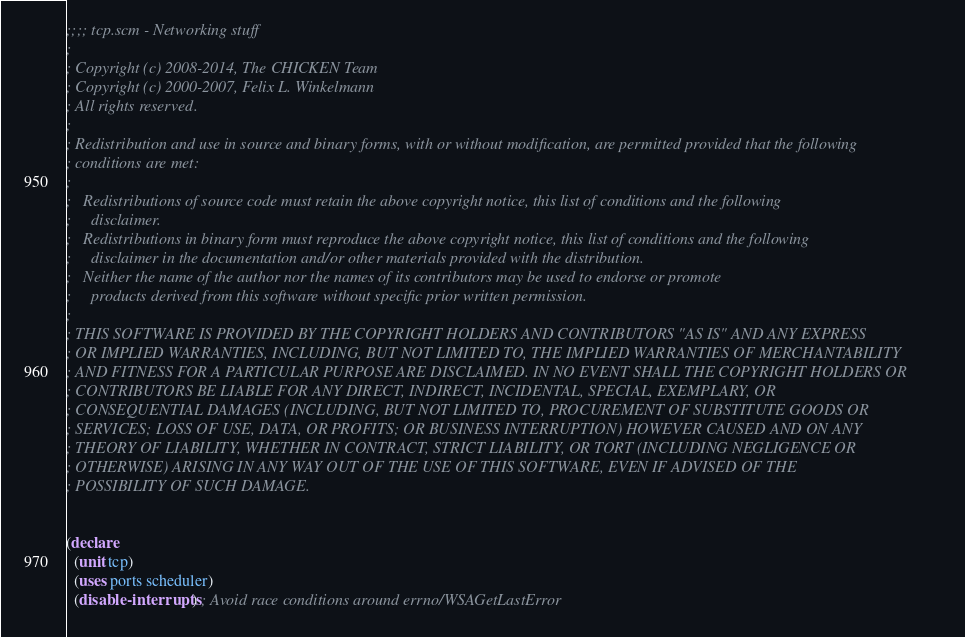Convert code to text. <code><loc_0><loc_0><loc_500><loc_500><_Scheme_>;;;; tcp.scm - Networking stuff
;
; Copyright (c) 2008-2014, The CHICKEN Team
; Copyright (c) 2000-2007, Felix L. Winkelmann
; All rights reserved.
;
; Redistribution and use in source and binary forms, with or without modification, are permitted provided that the following
; conditions are met:
;
;   Redistributions of source code must retain the above copyright notice, this list of conditions and the following
;     disclaimer. 
;   Redistributions in binary form must reproduce the above copyright notice, this list of conditions and the following
;     disclaimer in the documentation and/or other materials provided with the distribution. 
;   Neither the name of the author nor the names of its contributors may be used to endorse or promote
;     products derived from this software without specific prior written permission. 
;
; THIS SOFTWARE IS PROVIDED BY THE COPYRIGHT HOLDERS AND CONTRIBUTORS "AS IS" AND ANY EXPRESS
; OR IMPLIED WARRANTIES, INCLUDING, BUT NOT LIMITED TO, THE IMPLIED WARRANTIES OF MERCHANTABILITY
; AND FITNESS FOR A PARTICULAR PURPOSE ARE DISCLAIMED. IN NO EVENT SHALL THE COPYRIGHT HOLDERS OR
; CONTRIBUTORS BE LIABLE FOR ANY DIRECT, INDIRECT, INCIDENTAL, SPECIAL, EXEMPLARY, OR
; CONSEQUENTIAL DAMAGES (INCLUDING, BUT NOT LIMITED TO, PROCUREMENT OF SUBSTITUTE GOODS OR
; SERVICES; LOSS OF USE, DATA, OR PROFITS; OR BUSINESS INTERRUPTION) HOWEVER CAUSED AND ON ANY
; THEORY OF LIABILITY, WHETHER IN CONTRACT, STRICT LIABILITY, OR TORT (INCLUDING NEGLIGENCE OR
; OTHERWISE) ARISING IN ANY WAY OUT OF THE USE OF THIS SOFTWARE, EVEN IF ADVISED OF THE
; POSSIBILITY OF SUCH DAMAGE.


(declare
  (unit tcp)
  (uses ports scheduler)
  (disable-interrupts) ; Avoid race conditions around errno/WSAGetLastError</code> 